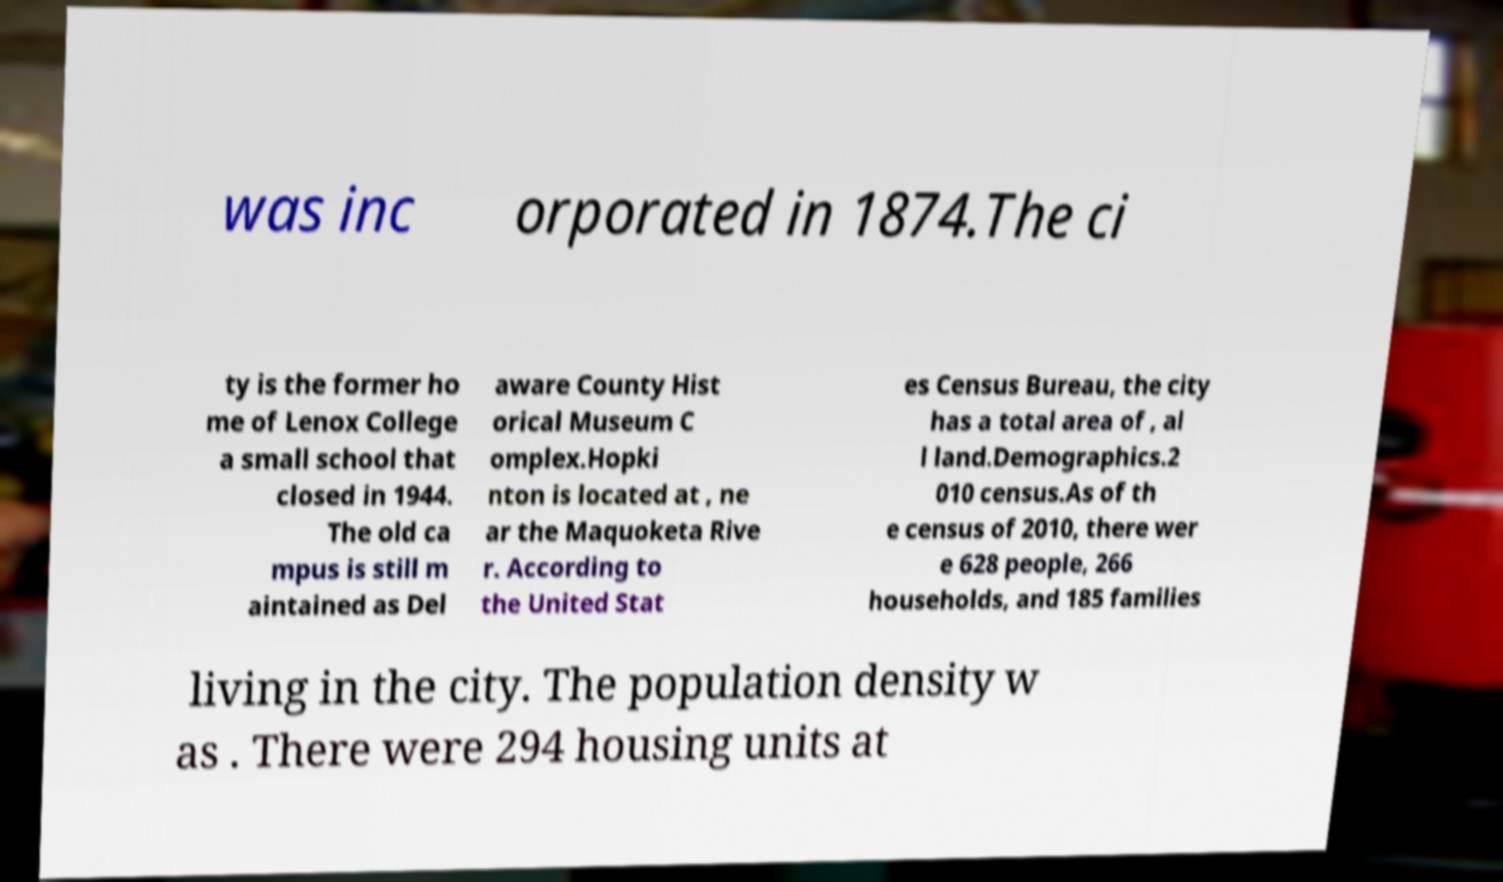For documentation purposes, I need the text within this image transcribed. Could you provide that? was inc orporated in 1874.The ci ty is the former ho me of Lenox College a small school that closed in 1944. The old ca mpus is still m aintained as Del aware County Hist orical Museum C omplex.Hopki nton is located at , ne ar the Maquoketa Rive r. According to the United Stat es Census Bureau, the city has a total area of , al l land.Demographics.2 010 census.As of th e census of 2010, there wer e 628 people, 266 households, and 185 families living in the city. The population density w as . There were 294 housing units at 